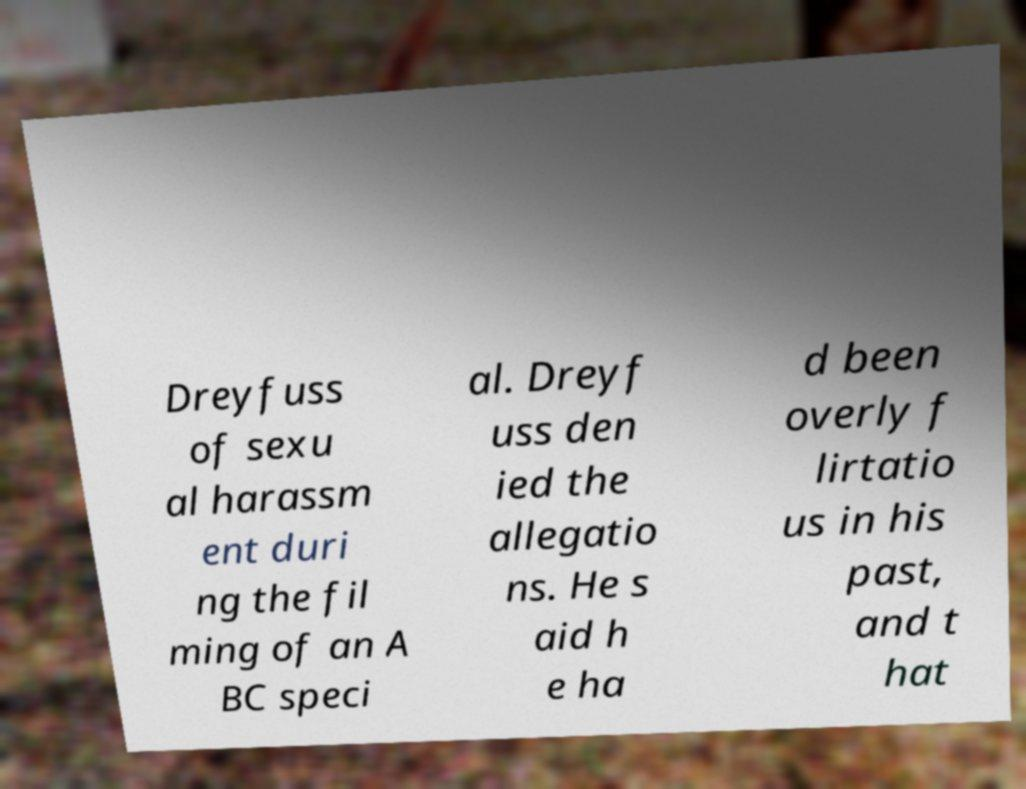I need the written content from this picture converted into text. Can you do that? Dreyfuss of sexu al harassm ent duri ng the fil ming of an A BC speci al. Dreyf uss den ied the allegatio ns. He s aid h e ha d been overly f lirtatio us in his past, and t hat 